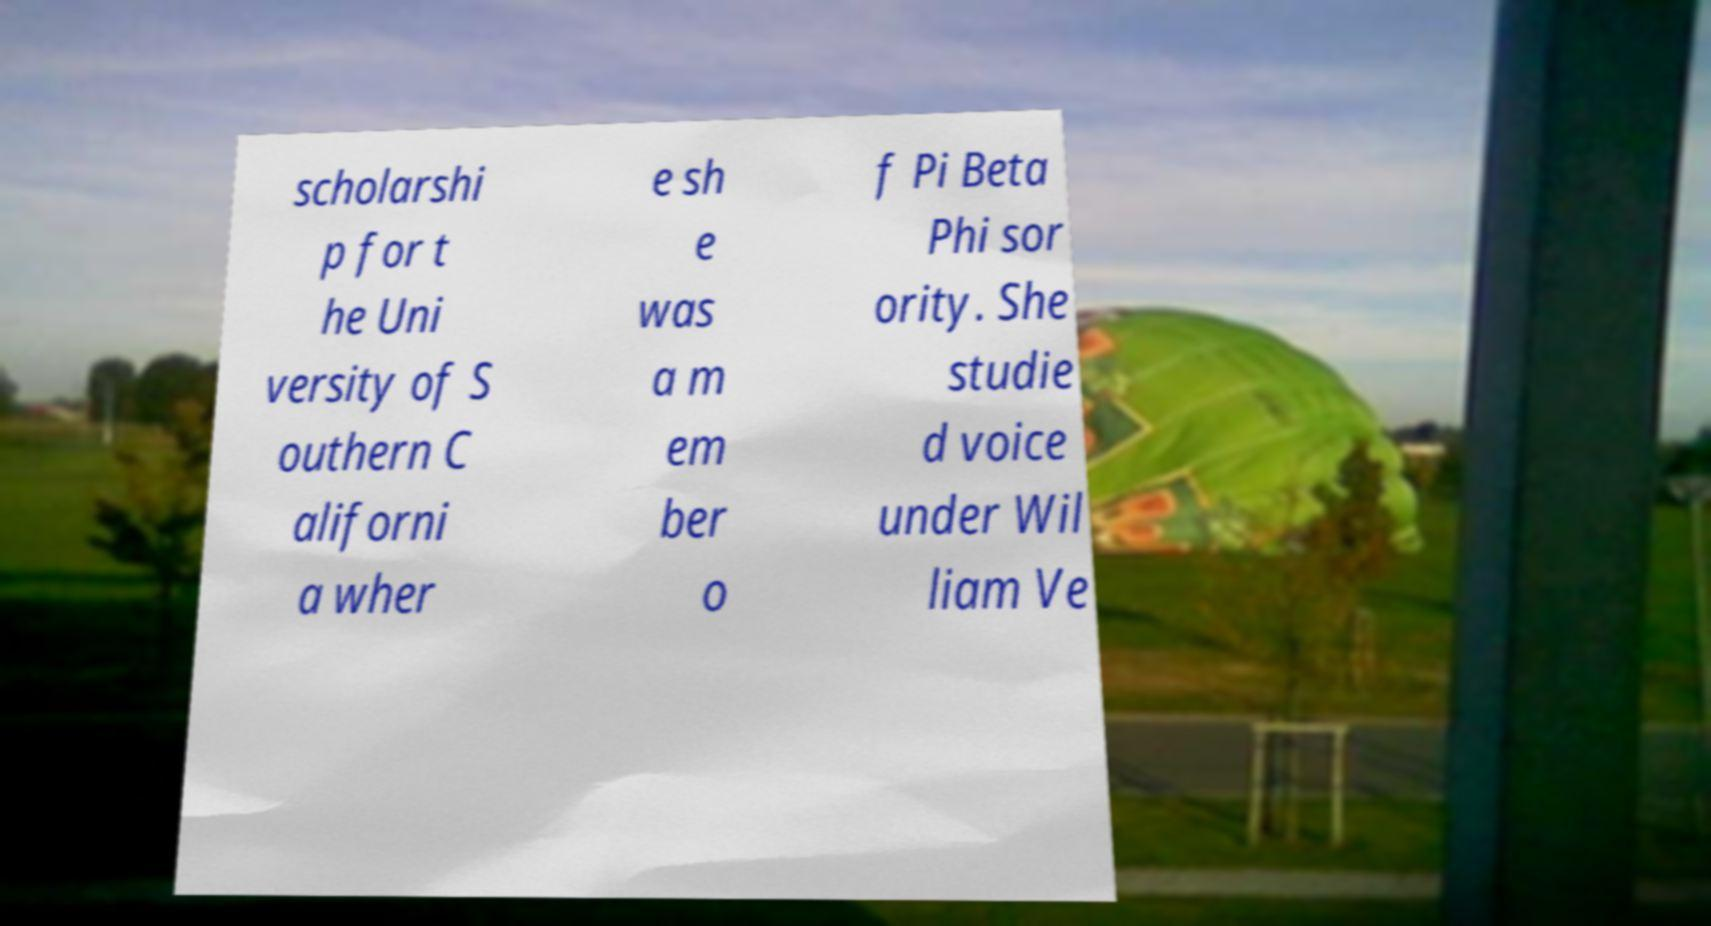I need the written content from this picture converted into text. Can you do that? scholarshi p for t he Uni versity of S outhern C aliforni a wher e sh e was a m em ber o f Pi Beta Phi sor ority. She studie d voice under Wil liam Ve 